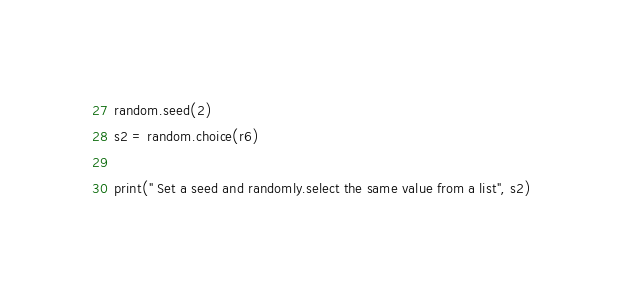Convert code to text. <code><loc_0><loc_0><loc_500><loc_500><_Python_>random.seed(2)
s2 = random.choice(r6)

print(" Set a seed and randomly.select the same value from a list", s2)
</code> 